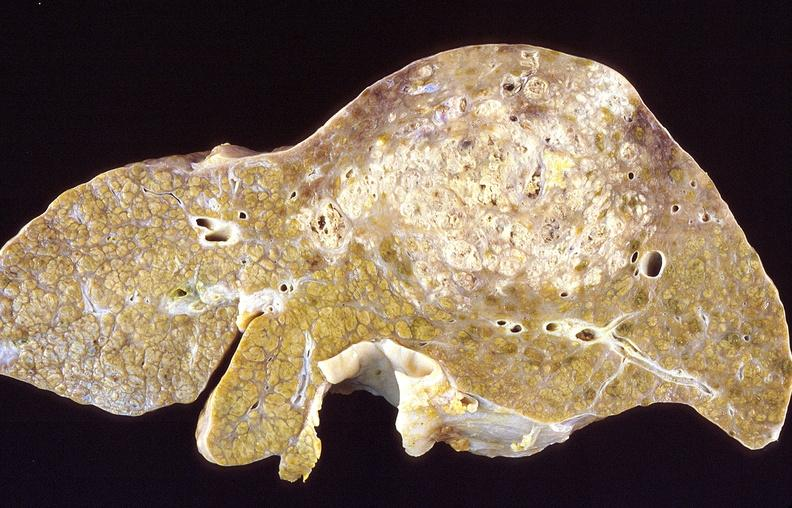what is present?
Answer the question using a single word or phrase. Liver 